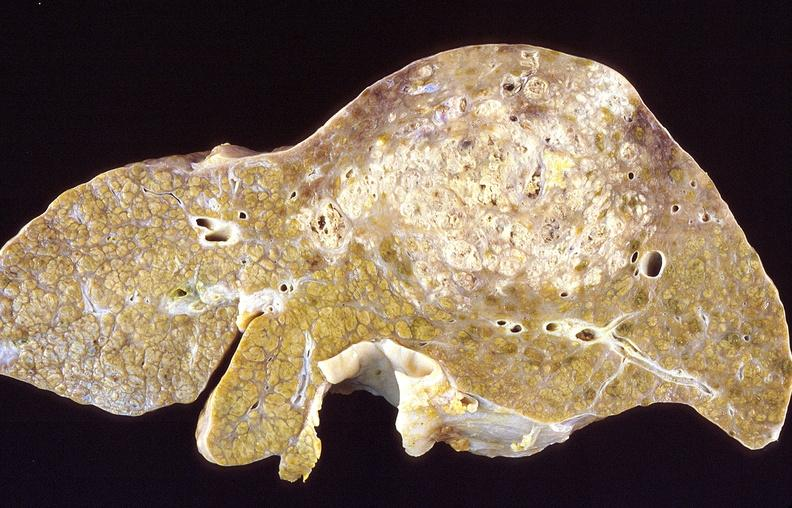what is present?
Answer the question using a single word or phrase. Liver 